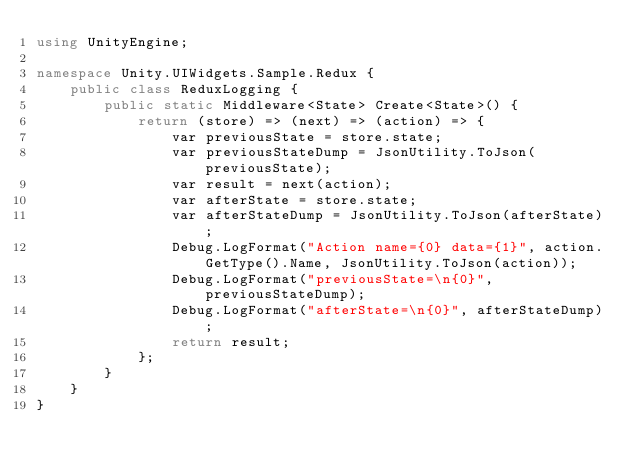Convert code to text. <code><loc_0><loc_0><loc_500><loc_500><_C#_>using UnityEngine;

namespace Unity.UIWidgets.Sample.Redux {
    public class ReduxLogging {
        public static Middleware<State> Create<State>() {
            return (store) => (next) => (action) => {
                var previousState = store.state;
                var previousStateDump = JsonUtility.ToJson(previousState);
                var result = next(action);
                var afterState = store.state;
                var afterStateDump = JsonUtility.ToJson(afterState);
                Debug.LogFormat("Action name={0} data={1}", action.GetType().Name, JsonUtility.ToJson(action));
                Debug.LogFormat("previousState=\n{0}", previousStateDump);
                Debug.LogFormat("afterState=\n{0}", afterStateDump);
                return result;
            };
        }
    }
}</code> 